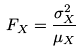Convert formula to latex. <formula><loc_0><loc_0><loc_500><loc_500>F _ { X } = \frac { \sigma _ { X } ^ { 2 } } { \mu _ { X } }</formula> 